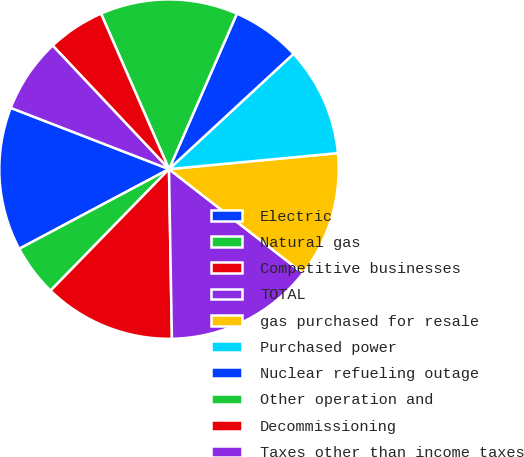Convert chart to OTSL. <chart><loc_0><loc_0><loc_500><loc_500><pie_chart><fcel>Electric<fcel>Natural gas<fcel>Competitive businesses<fcel>TOTAL<fcel>gas purchased for resale<fcel>Purchased power<fcel>Nuclear refueling outage<fcel>Other operation and<fcel>Decommissioning<fcel>Taxes other than income taxes<nl><fcel>13.66%<fcel>4.92%<fcel>12.57%<fcel>14.21%<fcel>12.02%<fcel>10.38%<fcel>6.56%<fcel>13.11%<fcel>5.46%<fcel>7.1%<nl></chart> 